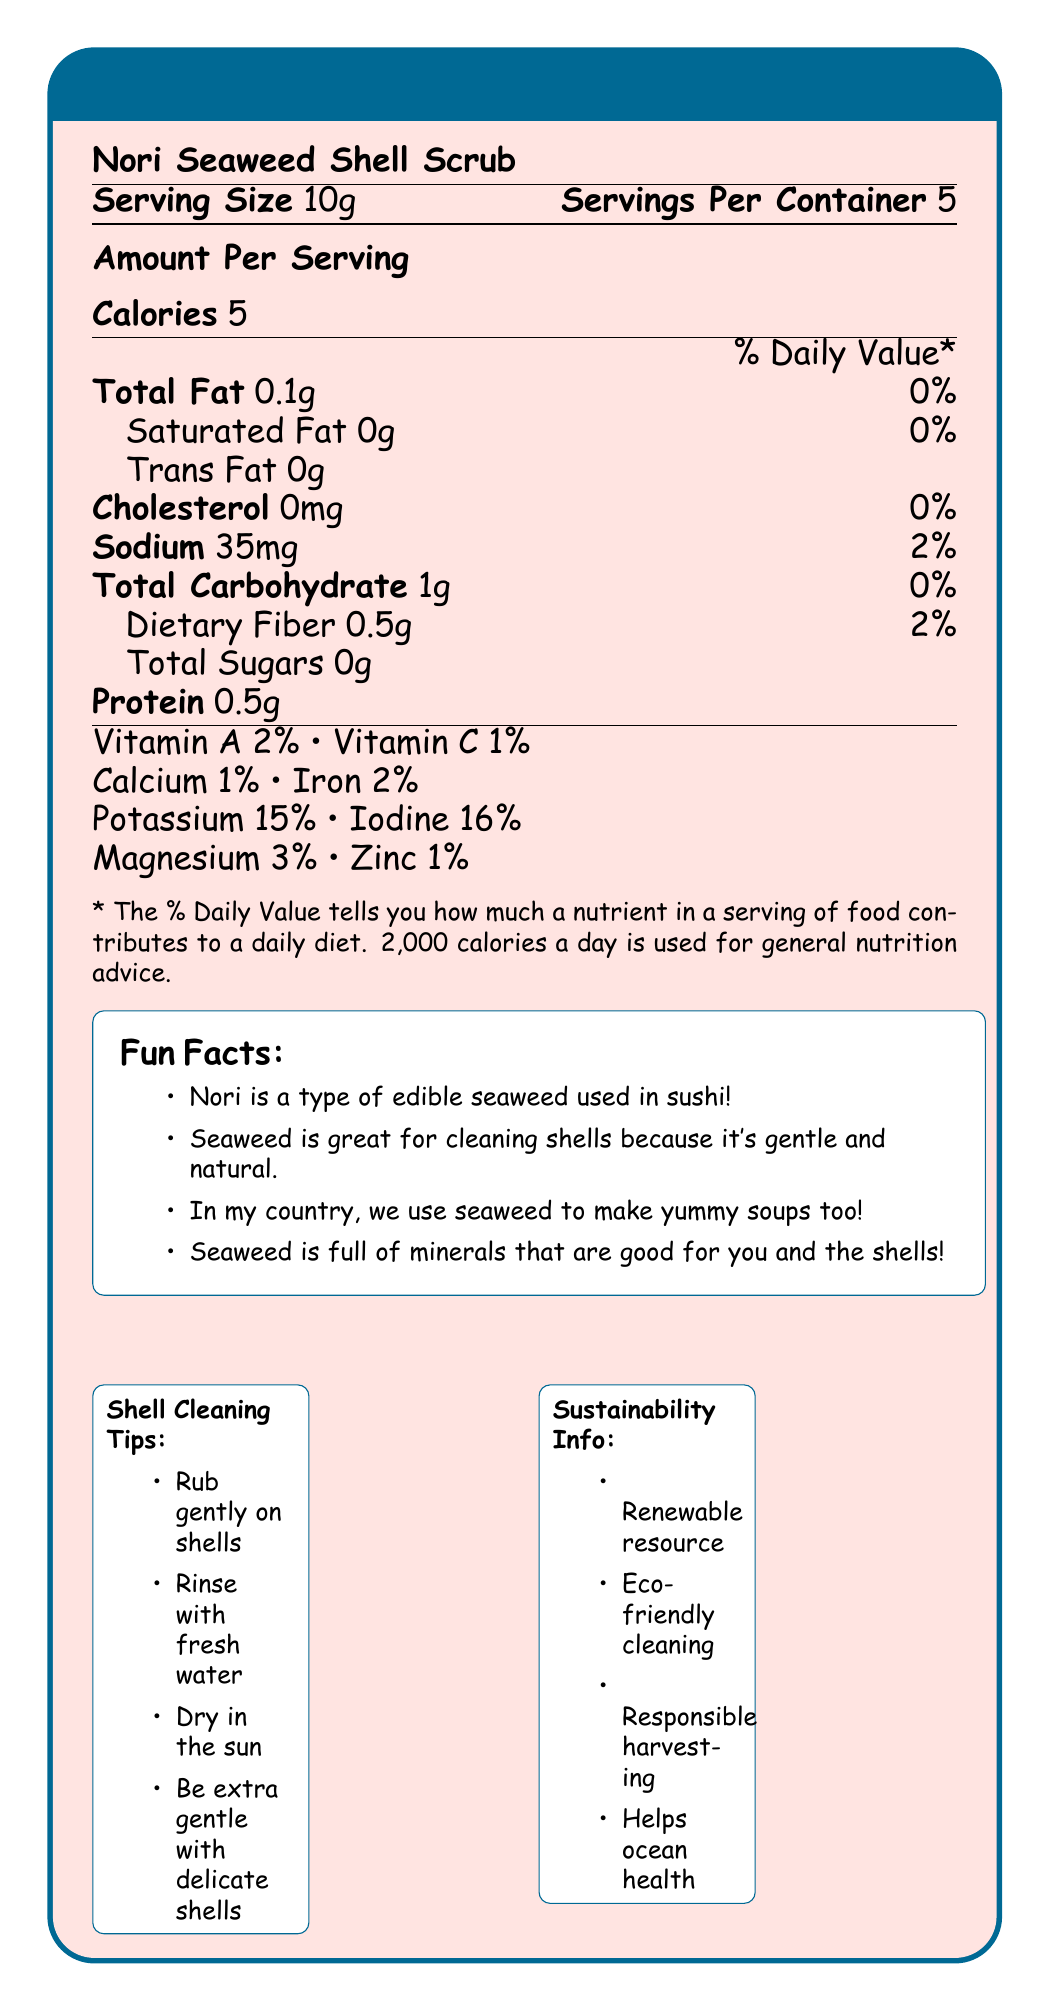what is the serving size of the Nori Seaweed Shell Scrub? The document states that the serving size is 10g, as listed under the product name.
Answer: 10g how many calories are in one serving of the Nori Seaweed Shell Scrub? The document specifies that there are 5 calories per serving.
Answer: 5 calories how much sodium is in one serving? The document states that each serving contains 35mg of sodium.
Answer: 35mg how many servings are in one container? The document indicates that there are 5 servings per container.
Answer: 5 what is the total fat percentage daily value for one serving? According to the document, the total fat in one serving is 0.1g, which is 0% of the daily value.
Answer: 0% which nutrient has the highest percentage daily value in one serving? A. Calcium B. Iron C. Iodine D. Magnesium The document shows that Iodine has the highest percentage daily value at 16%.
Answer: C. Iodine which vitamin in the Nori Seaweed Shell Scrub has a 2% daily value? A. Vitamin A B. Vitamin C C. Vitamin D D. Vitamin B12 The document indicates that Vitamin A has a 2% daily value.
Answer: A. Vitamin A can seaweed be used to clean delicate shells? The document provides a shell cleaning tip that advises being extra gentle with delicate shells.
Answer: Yes does the Nori Seaweed Shell Scrub contain any cholesterol? The document shows that the cholesterol content is 0mg.
Answer: No summarize the main idea of the document. The document includes nutritional details such as serving size, calories, and nutrient content. It also shares interesting facts about seaweed, cultural uses, eco-friendly aspects, and practical tips for cleaning shells.
Answer: The document provides nutritional information, fun facts, cultural notes, shell cleaning tips, and sustainability information about the Nori Seaweed Shell Scrub. how much protein is in one serving of the Nori Seaweed Shell Scrub? The document indicates that there is 0.5g of protein per serving.
Answer: 0.5g does the document mention the use of seaweed in traditional medicine? The document notes that some Pacific Island cultures use seaweed in traditional medicine.
Answer: Yes is the Nori Seaweed Shell Scrub considered to be eco-friendly? The document mentions that using seaweed for cleaning is eco-friendly and safe for ocean life.
Answer: Yes can you tell the price of the Nori Seaweed Shell Scrub from the document? The document does not provide any information about the price of the product.
Answer: Not enough information how should shells be cleaned after using seaweed on them? One of the shell cleaning tips in the document advises rinsing the shell with fresh water after cleaning.
Answer: Rinse the shell with fresh water after cleaning. mention one fun fact about nori from the document. The document states that nori is a type of edible seaweed used in sushi.
Answer: Nori is a type of edible seaweed used in sushi! 